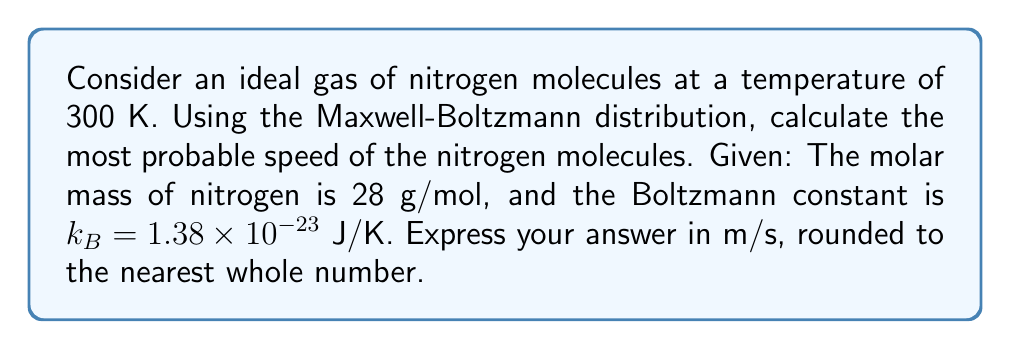What is the answer to this math problem? Let's approach this step-by-step:

1) The Maxwell-Boltzmann distribution gives the probability density of molecular speeds in an ideal gas. The most probable speed, $v_p$, is given by:

   $$v_p = \sqrt{\frac{2k_BT}{m}}$$

   where $k_B$ is the Boltzmann constant, $T$ is the temperature, and $m$ is the mass of a single molecule.

2) We're given $k_B = 1.38 \times 10^{-23}$ J/K and $T = 300$ K.

3) We need to calculate $m$. We're given the molar mass of nitrogen (28 g/mol), but we need the mass of a single molecule:

   $$m = \frac{28 \text{ g/mol}}{6.022 \times 10^{23} \text{ molecules/mol}} = 4.65 \times 10^{-26} \text{ kg}$$

4) Now we can substitute these values into our equation:

   $$v_p = \sqrt{\frac{2(1.38 \times 10^{-23} \text{ J/K})(300 \text{ K})}{4.65 \times 10^{-26} \text{ kg}}}$$

5) Simplifying:

   $$v_p = \sqrt{\frac{8.28 \times 10^{-21}}{4.65 \times 10^{-26}}} = \sqrt{1.78 \times 10^5} = 422.14 \text{ m/s}$$

6) Rounding to the nearest whole number:

   $$v_p \approx 422 \text{ m/s}$$
Answer: 422 m/s 